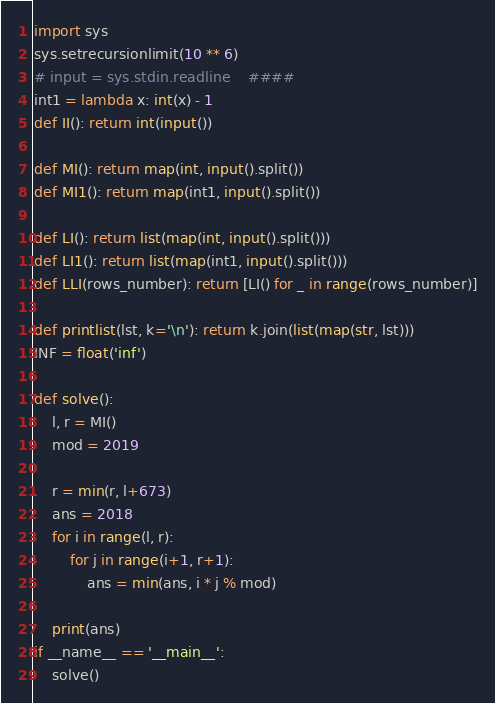<code> <loc_0><loc_0><loc_500><loc_500><_Python_>import sys
sys.setrecursionlimit(10 ** 6)
# input = sys.stdin.readline    ####
int1 = lambda x: int(x) - 1
def II(): return int(input())

def MI(): return map(int, input().split())
def MI1(): return map(int1, input().split())

def LI(): return list(map(int, input().split()))
def LI1(): return list(map(int1, input().split()))
def LLI(rows_number): return [LI() for _ in range(rows_number)]

def printlist(lst, k='\n'): return k.join(list(map(str, lst)))
INF = float('inf')

def solve():
    l, r = MI()
    mod = 2019

    r = min(r, l+673)
    ans = 2018
    for i in range(l, r):
        for j in range(i+1, r+1):
            ans = min(ans, i * j % mod)

    print(ans)
if __name__ == '__main__':
    solve()
</code> 